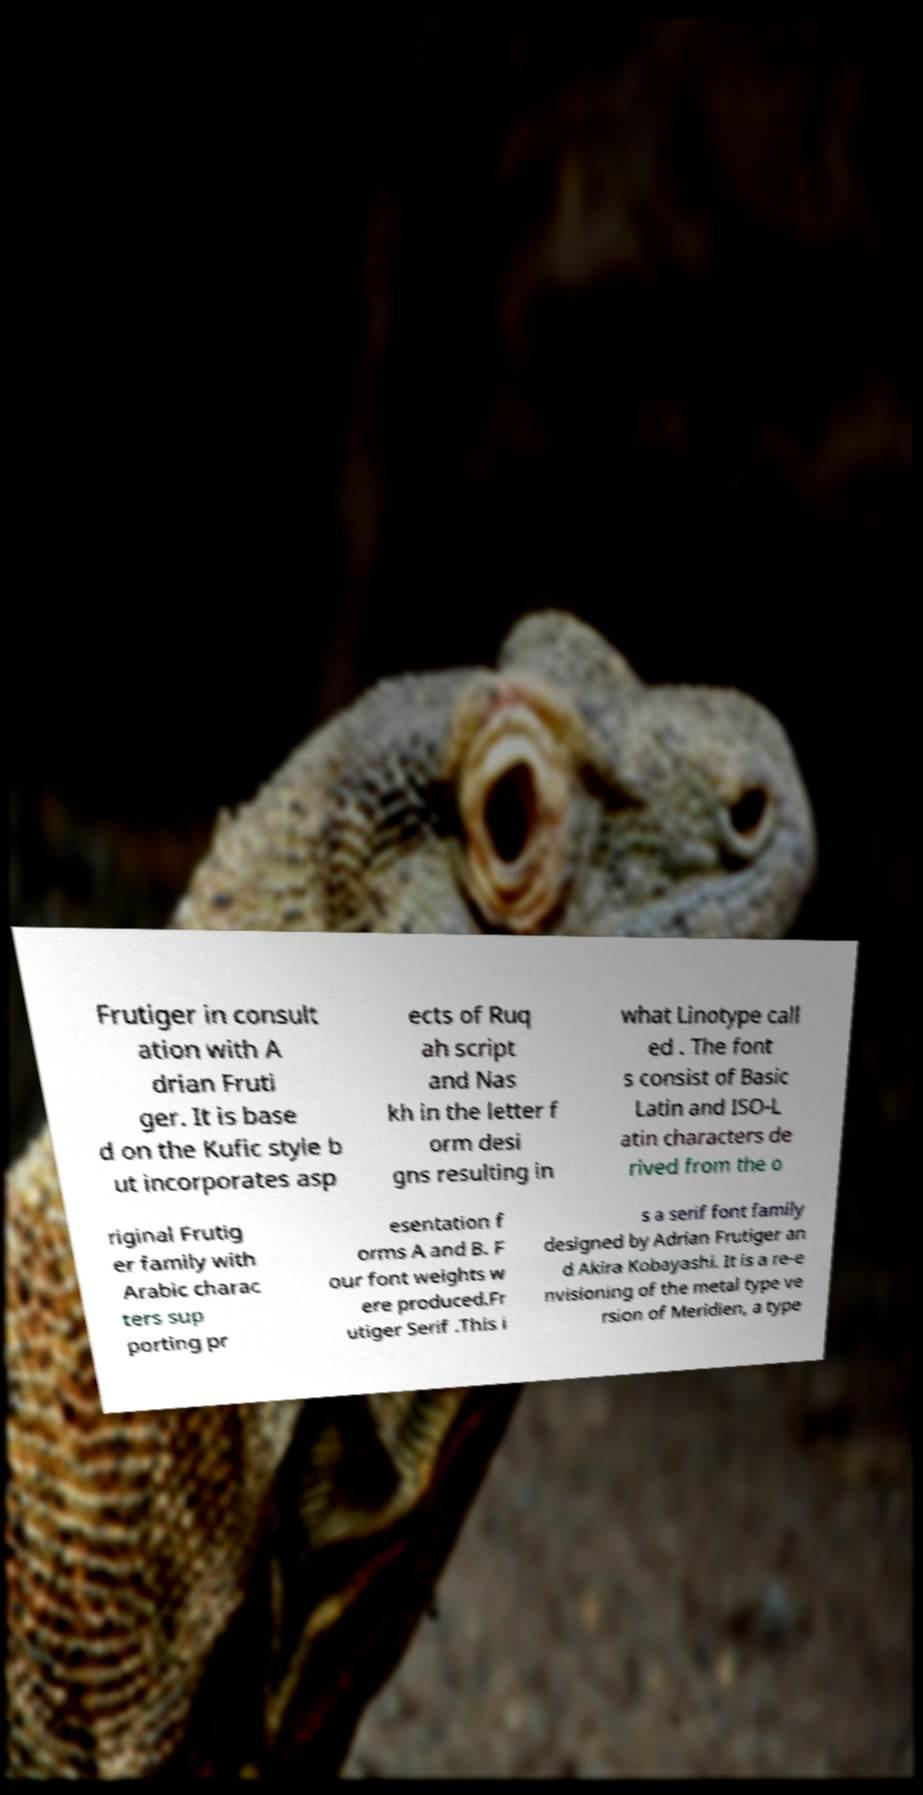Can you accurately transcribe the text from the provided image for me? Frutiger in consult ation with A drian Fruti ger. It is base d on the Kufic style b ut incorporates asp ects of Ruq ah script and Nas kh in the letter f orm desi gns resulting in what Linotype call ed . The font s consist of Basic Latin and ISO-L atin characters de rived from the o riginal Frutig er family with Arabic charac ters sup porting pr esentation f orms A and B. F our font weights w ere produced.Fr utiger Serif .This i s a serif font family designed by Adrian Frutiger an d Akira Kobayashi. It is a re-e nvisioning of the metal type ve rsion of Meridien, a type 